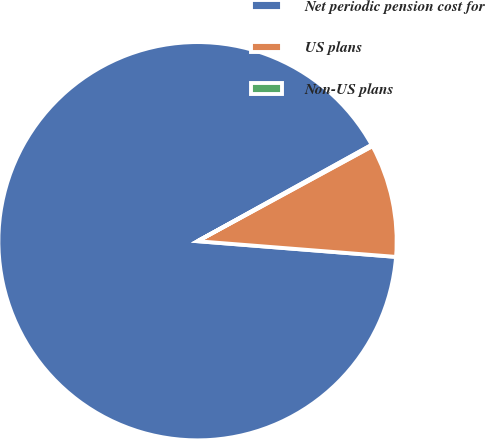Convert chart. <chart><loc_0><loc_0><loc_500><loc_500><pie_chart><fcel>Net periodic pension cost for<fcel>US plans<fcel>Non-US plans<nl><fcel>90.71%<fcel>9.18%<fcel>0.12%<nl></chart> 